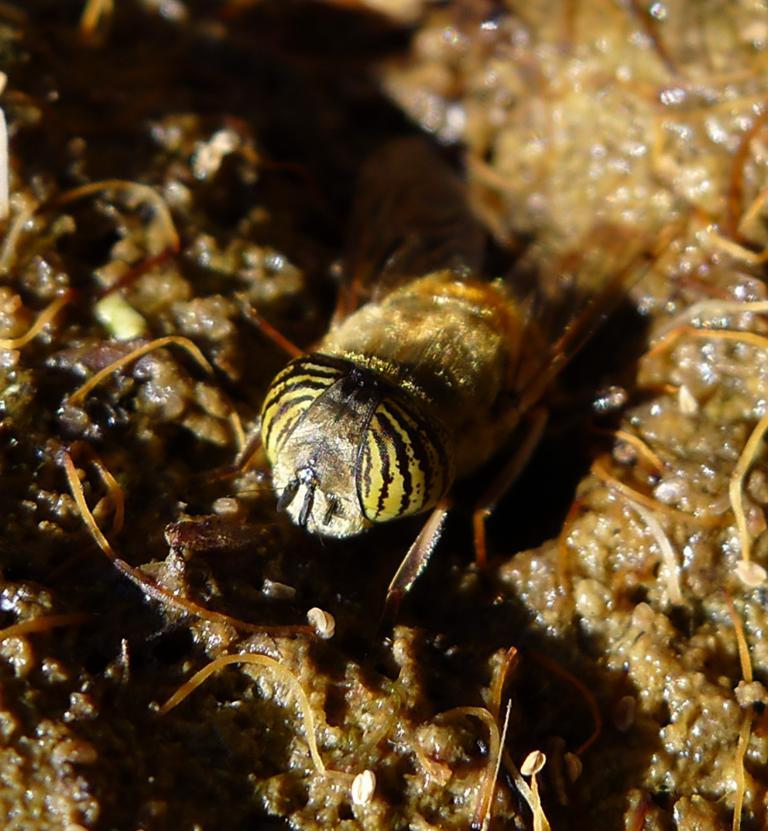What type of creature is present in the image? There is an insect in the image. What is the insect's environment like in the image? The insect is on a wet surface. How does the insect twist the copy of the seed in the image? There is no copy of a seed present in the image, and the insect is not twisting anything. 